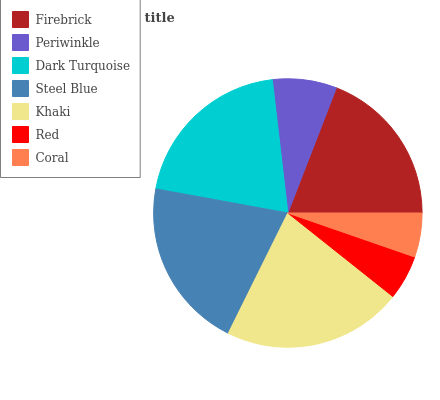Is Coral the minimum?
Answer yes or no. Yes. Is Khaki the maximum?
Answer yes or no. Yes. Is Periwinkle the minimum?
Answer yes or no. No. Is Periwinkle the maximum?
Answer yes or no. No. Is Firebrick greater than Periwinkle?
Answer yes or no. Yes. Is Periwinkle less than Firebrick?
Answer yes or no. Yes. Is Periwinkle greater than Firebrick?
Answer yes or no. No. Is Firebrick less than Periwinkle?
Answer yes or no. No. Is Firebrick the high median?
Answer yes or no. Yes. Is Firebrick the low median?
Answer yes or no. Yes. Is Red the high median?
Answer yes or no. No. Is Coral the low median?
Answer yes or no. No. 